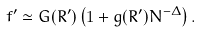Convert formula to latex. <formula><loc_0><loc_0><loc_500><loc_500>f ^ { \prime } \simeq G ( R ^ { \prime } ) \left ( 1 + g ( R ^ { \prime } ) N ^ { - \Delta } \right ) .</formula> 